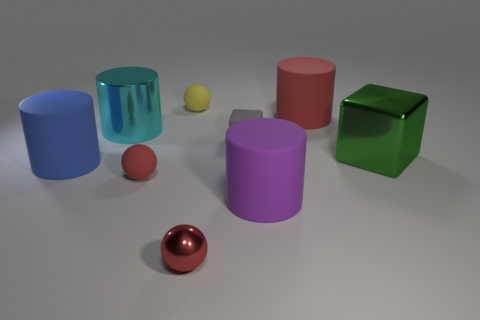Is the number of yellow things that are in front of the red matte ball greater than the number of metallic blocks in front of the large blue thing?
Ensure brevity in your answer.  No. What shape is the metallic object that is both right of the small yellow object and left of the large green object?
Provide a succinct answer. Sphere. There is a tiny red object that is behind the purple matte cylinder; what shape is it?
Ensure brevity in your answer.  Sphere. There is a blue thing in front of the large metal thing that is behind the big green shiny cube that is in front of the gray rubber object; how big is it?
Your response must be concise. Large. Does the small red rubber thing have the same shape as the red metal object?
Provide a succinct answer. Yes. What is the size of the cylinder that is both in front of the big cube and to the right of the blue matte thing?
Offer a terse response. Large. There is a big red thing that is the same shape as the cyan object; what is its material?
Provide a succinct answer. Rubber. What material is the large red object on the right side of the small matte object that is in front of the tiny gray matte cube?
Give a very brief answer. Rubber. Is the shape of the small yellow object the same as the red thing left of the yellow sphere?
Provide a succinct answer. Yes. How many matte things are either big green things or blue objects?
Make the answer very short. 1. 